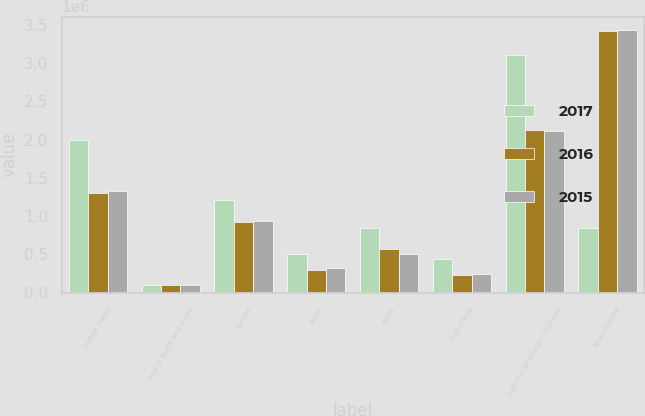Convert chart. <chart><loc_0><loc_0><loc_500><loc_500><stacked_bar_chart><ecel><fcel>United States<fcel>Rest of North and South<fcel>Europe<fcel>Japan<fcel>China<fcel>Rest ofAsia<fcel>Subtotal all foreign countries<fcel>Total revenue<nl><fcel>2017<fcel>1.99904e+06<fcel>103077<fcel>1.21144e+06<fcel>506114<fcel>842532<fcel>445304<fcel>3.10846e+06<fcel>842532<nl><fcel>2016<fcel>1.29963e+06<fcel>95957<fcel>924849<fcel>291649<fcel>575690<fcel>233635<fcel>2.12178e+06<fcel>3.42141e+06<nl><fcel>2015<fcel>1.32528e+06<fcel>97189<fcel>939230<fcel>319569<fcel>511365<fcel>242460<fcel>2.10981e+06<fcel>3.43509e+06<nl></chart> 